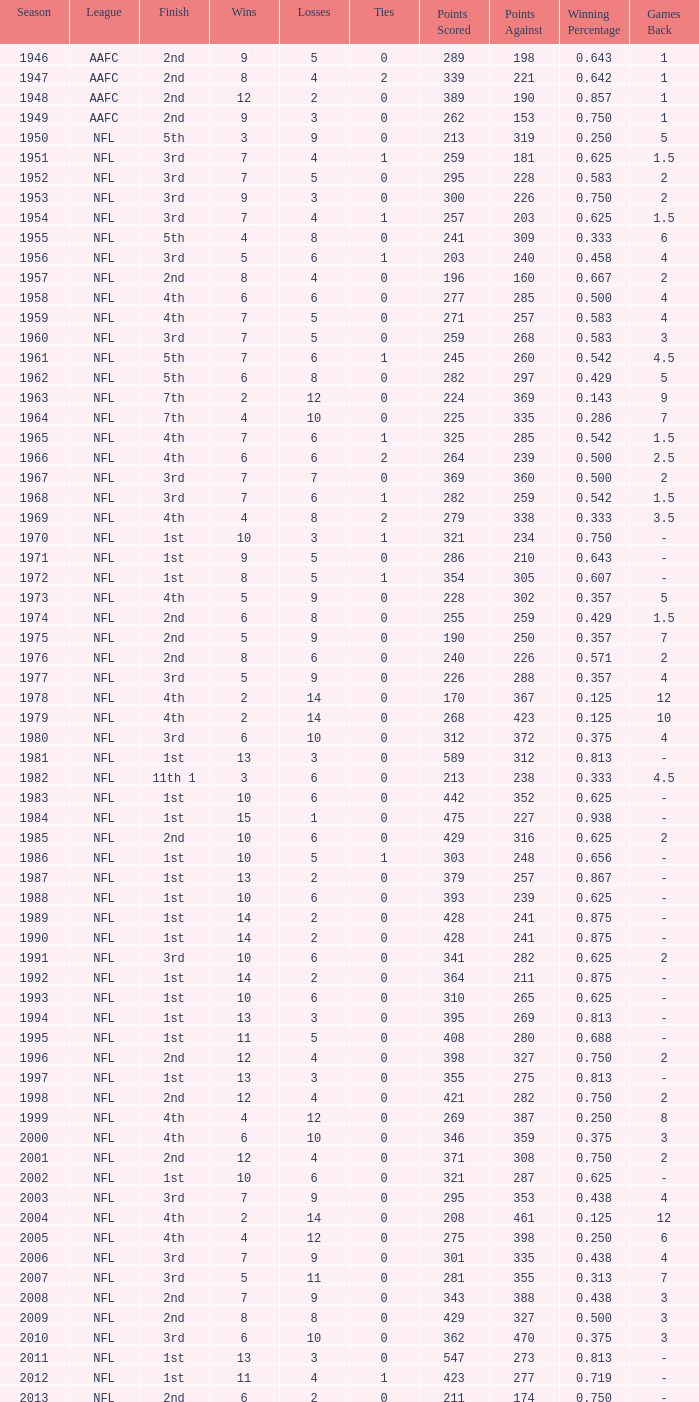What is the highest wins for the NFL with a finish of 1st, and more than 6 losses? None. 